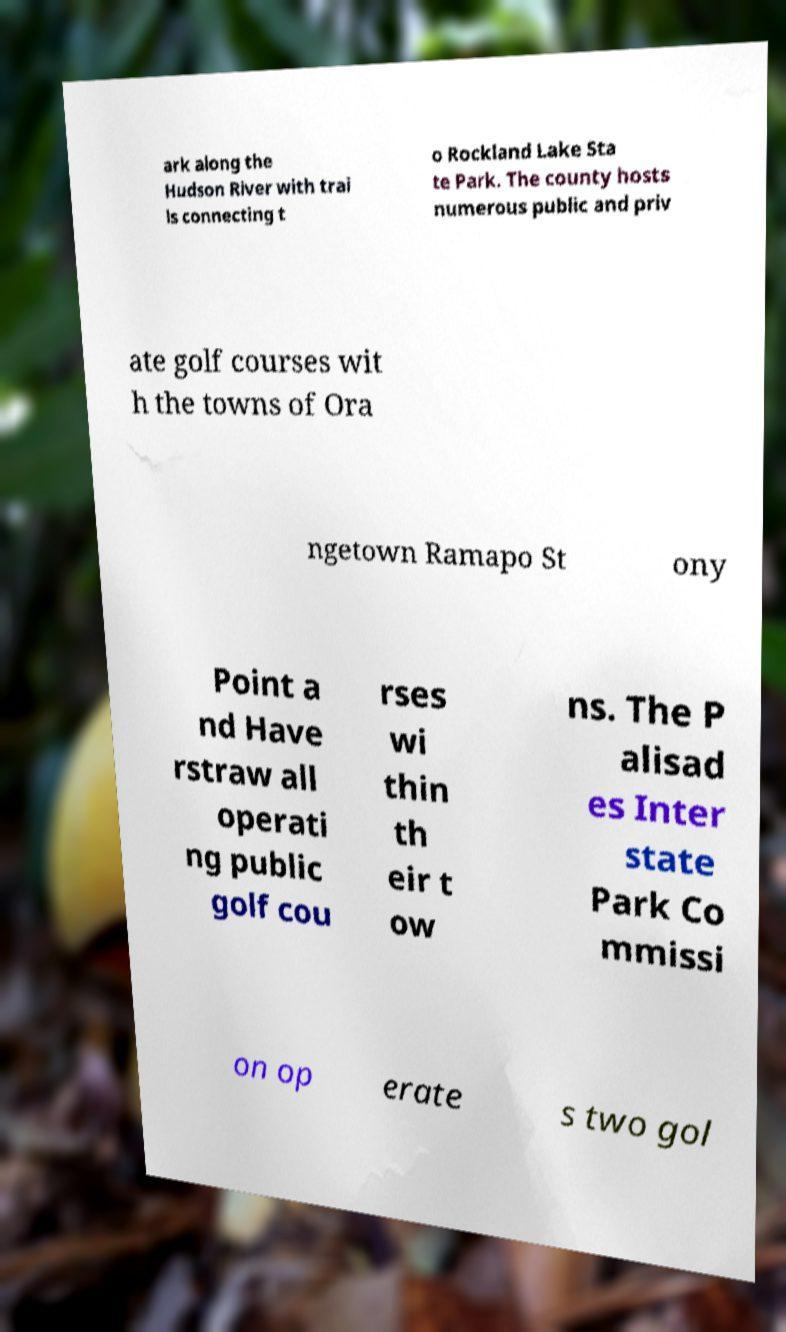Please read and relay the text visible in this image. What does it say? ark along the Hudson River with trai ls connecting t o Rockland Lake Sta te Park. The county hosts numerous public and priv ate golf courses wit h the towns of Ora ngetown Ramapo St ony Point a nd Have rstraw all operati ng public golf cou rses wi thin th eir t ow ns. The P alisad es Inter state Park Co mmissi on op erate s two gol 